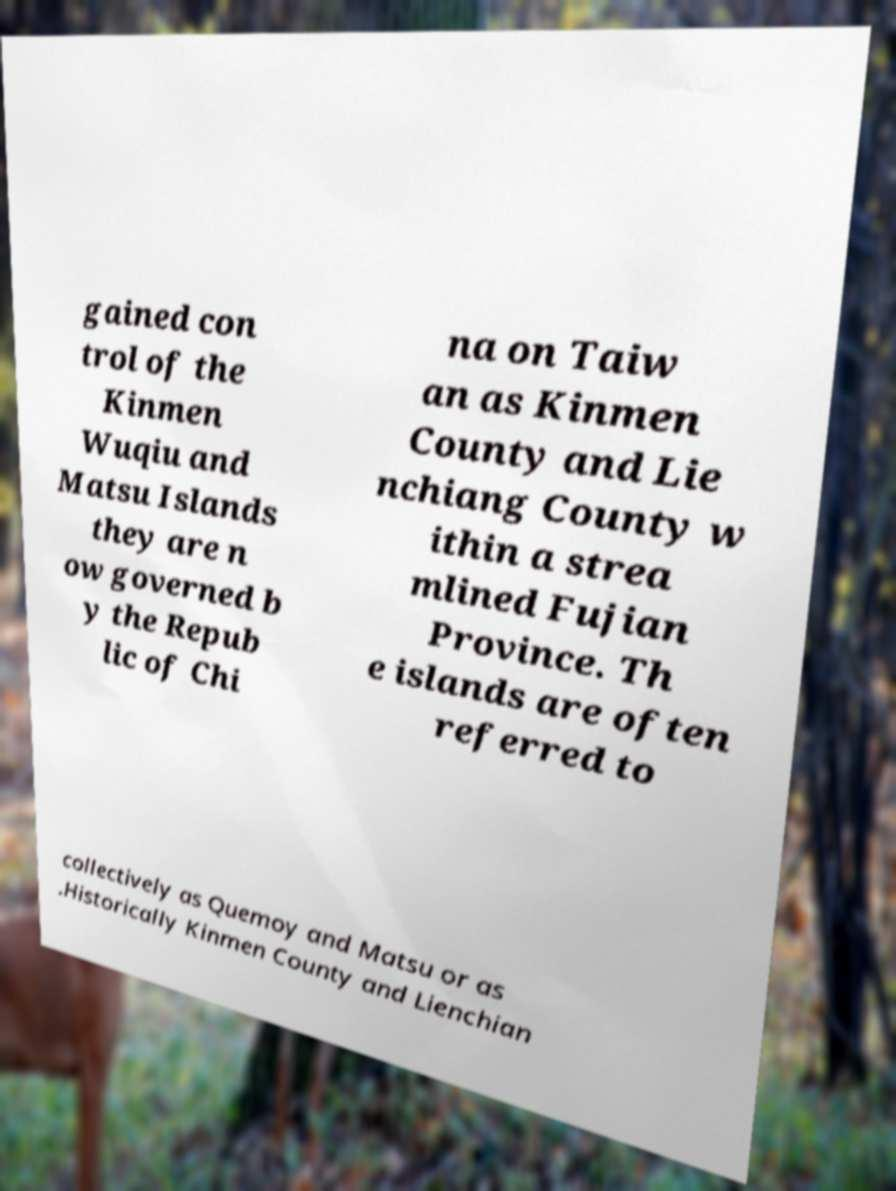What messages or text are displayed in this image? I need them in a readable, typed format. gained con trol of the Kinmen Wuqiu and Matsu Islands they are n ow governed b y the Repub lic of Chi na on Taiw an as Kinmen County and Lie nchiang County w ithin a strea mlined Fujian Province. Th e islands are often referred to collectively as Quemoy and Matsu or as .Historically Kinmen County and Lienchian 